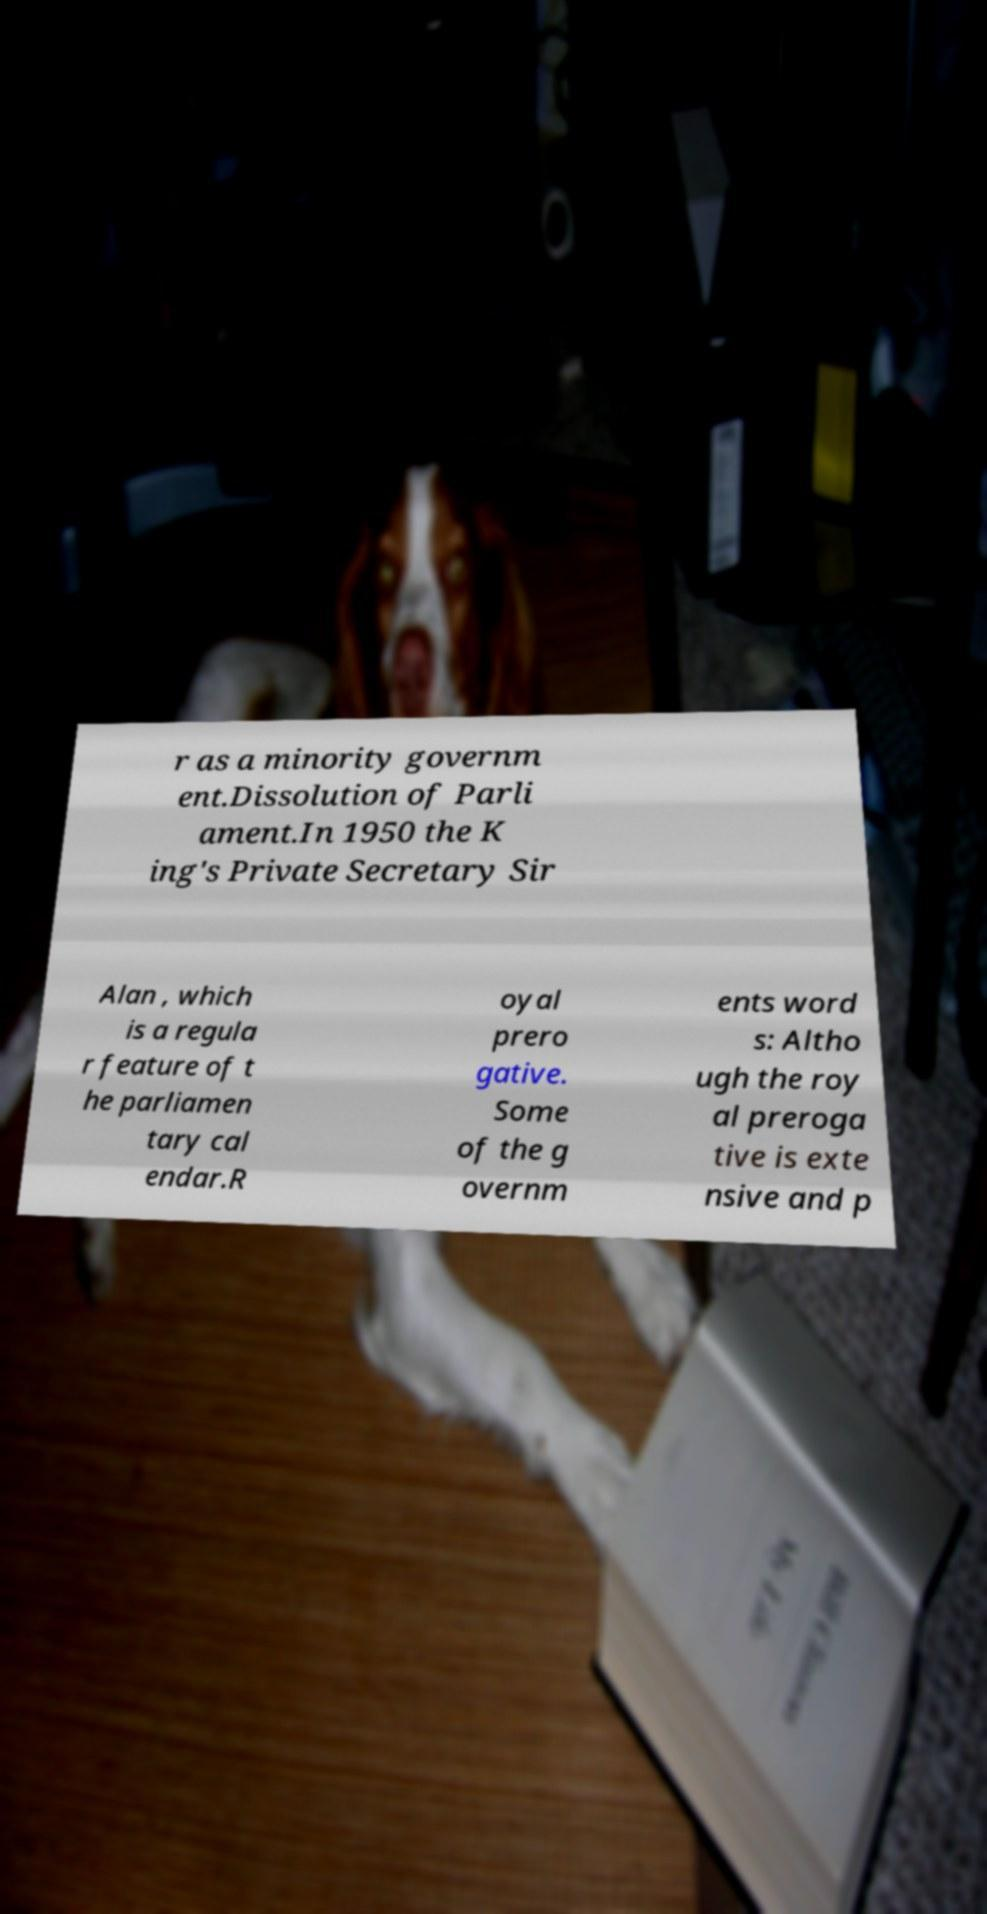There's text embedded in this image that I need extracted. Can you transcribe it verbatim? r as a minority governm ent.Dissolution of Parli ament.In 1950 the K ing's Private Secretary Sir Alan , which is a regula r feature of t he parliamen tary cal endar.R oyal prero gative. Some of the g overnm ents word s: Altho ugh the roy al preroga tive is exte nsive and p 